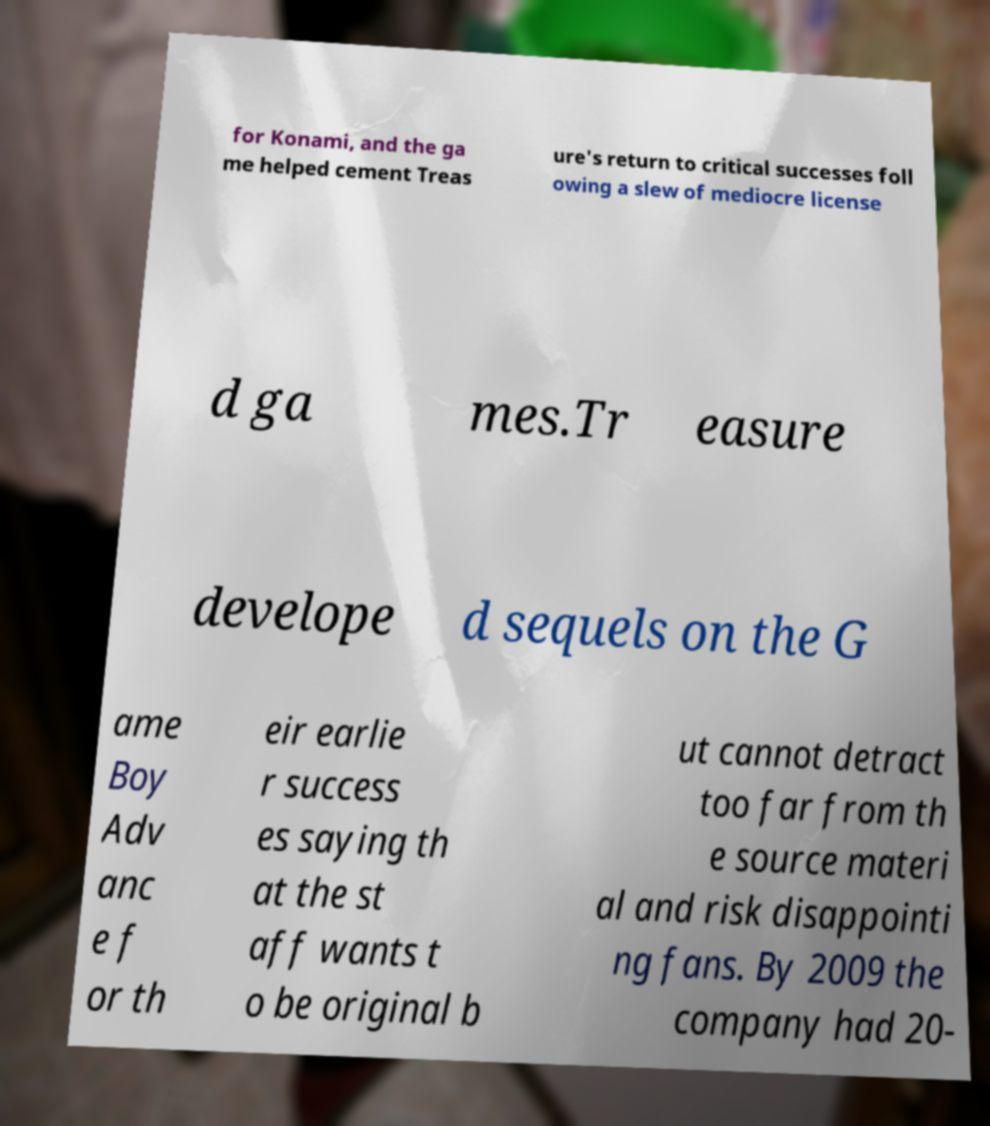Could you assist in decoding the text presented in this image and type it out clearly? for Konami, and the ga me helped cement Treas ure's return to critical successes foll owing a slew of mediocre license d ga mes.Tr easure develope d sequels on the G ame Boy Adv anc e f or th eir earlie r success es saying th at the st aff wants t o be original b ut cannot detract too far from th e source materi al and risk disappointi ng fans. By 2009 the company had 20- 